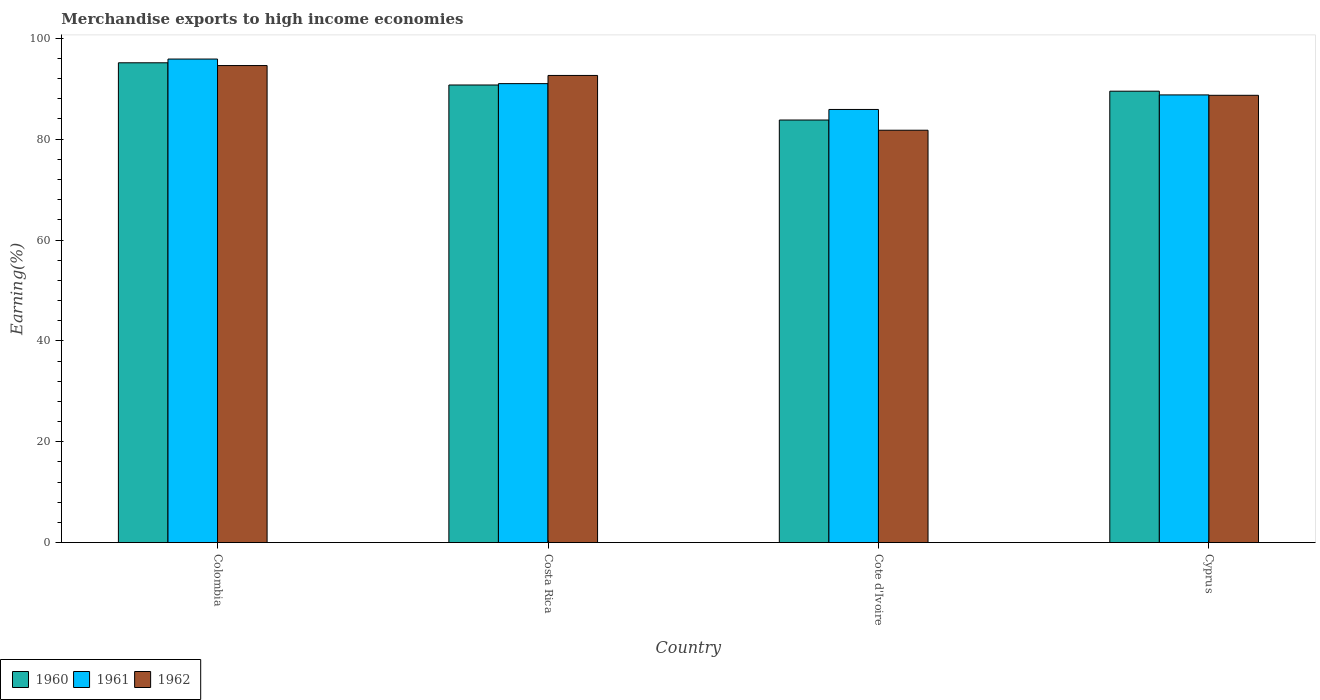How many groups of bars are there?
Make the answer very short. 4. Are the number of bars per tick equal to the number of legend labels?
Give a very brief answer. Yes. Are the number of bars on each tick of the X-axis equal?
Offer a very short reply. Yes. How many bars are there on the 4th tick from the left?
Offer a terse response. 3. How many bars are there on the 1st tick from the right?
Your answer should be very brief. 3. What is the percentage of amount earned from merchandise exports in 1962 in Costa Rica?
Provide a short and direct response. 92.64. Across all countries, what is the maximum percentage of amount earned from merchandise exports in 1960?
Provide a short and direct response. 95.14. Across all countries, what is the minimum percentage of amount earned from merchandise exports in 1961?
Make the answer very short. 85.89. In which country was the percentage of amount earned from merchandise exports in 1961 maximum?
Your answer should be very brief. Colombia. In which country was the percentage of amount earned from merchandise exports in 1961 minimum?
Ensure brevity in your answer.  Cote d'Ivoire. What is the total percentage of amount earned from merchandise exports in 1962 in the graph?
Ensure brevity in your answer.  357.7. What is the difference between the percentage of amount earned from merchandise exports in 1962 in Costa Rica and that in Cote d'Ivoire?
Make the answer very short. 10.87. What is the difference between the percentage of amount earned from merchandise exports in 1962 in Cyprus and the percentage of amount earned from merchandise exports in 1961 in Colombia?
Keep it short and to the point. -7.19. What is the average percentage of amount earned from merchandise exports in 1960 per country?
Give a very brief answer. 89.8. What is the difference between the percentage of amount earned from merchandise exports of/in 1961 and percentage of amount earned from merchandise exports of/in 1962 in Cyprus?
Make the answer very short. 0.08. In how many countries, is the percentage of amount earned from merchandise exports in 1962 greater than 72 %?
Offer a terse response. 4. What is the ratio of the percentage of amount earned from merchandise exports in 1960 in Colombia to that in Cyprus?
Make the answer very short. 1.06. Is the difference between the percentage of amount earned from merchandise exports in 1961 in Colombia and Cyprus greater than the difference between the percentage of amount earned from merchandise exports in 1962 in Colombia and Cyprus?
Your response must be concise. Yes. What is the difference between the highest and the second highest percentage of amount earned from merchandise exports in 1960?
Your answer should be very brief. -1.23. What is the difference between the highest and the lowest percentage of amount earned from merchandise exports in 1961?
Offer a terse response. 10. Is the sum of the percentage of amount earned from merchandise exports in 1960 in Colombia and Cyprus greater than the maximum percentage of amount earned from merchandise exports in 1962 across all countries?
Your response must be concise. Yes. What does the 1st bar from the right in Costa Rica represents?
Provide a succinct answer. 1962. How many bars are there?
Provide a short and direct response. 12. Are all the bars in the graph horizontal?
Keep it short and to the point. No. Are the values on the major ticks of Y-axis written in scientific E-notation?
Your answer should be very brief. No. How are the legend labels stacked?
Give a very brief answer. Horizontal. What is the title of the graph?
Offer a terse response. Merchandise exports to high income economies. What is the label or title of the Y-axis?
Offer a terse response. Earning(%). What is the Earning(%) of 1960 in Colombia?
Give a very brief answer. 95.14. What is the Earning(%) in 1961 in Colombia?
Keep it short and to the point. 95.89. What is the Earning(%) of 1962 in Colombia?
Make the answer very short. 94.6. What is the Earning(%) of 1960 in Costa Rica?
Your answer should be compact. 90.74. What is the Earning(%) in 1961 in Costa Rica?
Ensure brevity in your answer.  91.01. What is the Earning(%) in 1962 in Costa Rica?
Offer a very short reply. 92.64. What is the Earning(%) of 1960 in Cote d'Ivoire?
Provide a short and direct response. 83.8. What is the Earning(%) in 1961 in Cote d'Ivoire?
Offer a very short reply. 85.89. What is the Earning(%) in 1962 in Cote d'Ivoire?
Offer a very short reply. 81.77. What is the Earning(%) of 1960 in Cyprus?
Give a very brief answer. 89.51. What is the Earning(%) of 1961 in Cyprus?
Offer a terse response. 88.78. What is the Earning(%) of 1962 in Cyprus?
Give a very brief answer. 88.7. Across all countries, what is the maximum Earning(%) in 1960?
Make the answer very short. 95.14. Across all countries, what is the maximum Earning(%) in 1961?
Provide a short and direct response. 95.89. Across all countries, what is the maximum Earning(%) in 1962?
Provide a succinct answer. 94.6. Across all countries, what is the minimum Earning(%) of 1960?
Your answer should be very brief. 83.8. Across all countries, what is the minimum Earning(%) of 1961?
Provide a succinct answer. 85.89. Across all countries, what is the minimum Earning(%) in 1962?
Your answer should be very brief. 81.77. What is the total Earning(%) in 1960 in the graph?
Your answer should be compact. 359.19. What is the total Earning(%) of 1961 in the graph?
Your answer should be very brief. 361.56. What is the total Earning(%) in 1962 in the graph?
Your answer should be very brief. 357.7. What is the difference between the Earning(%) of 1960 in Colombia and that in Costa Rica?
Your answer should be compact. 4.4. What is the difference between the Earning(%) of 1961 in Colombia and that in Costa Rica?
Provide a succinct answer. 4.87. What is the difference between the Earning(%) of 1962 in Colombia and that in Costa Rica?
Provide a succinct answer. 1.96. What is the difference between the Earning(%) in 1960 in Colombia and that in Cote d'Ivoire?
Provide a succinct answer. 11.35. What is the difference between the Earning(%) of 1961 in Colombia and that in Cote d'Ivoire?
Keep it short and to the point. 10. What is the difference between the Earning(%) of 1962 in Colombia and that in Cote d'Ivoire?
Give a very brief answer. 12.83. What is the difference between the Earning(%) in 1960 in Colombia and that in Cyprus?
Your answer should be very brief. 5.63. What is the difference between the Earning(%) of 1961 in Colombia and that in Cyprus?
Give a very brief answer. 7.11. What is the difference between the Earning(%) of 1962 in Colombia and that in Cyprus?
Your answer should be very brief. 5.9. What is the difference between the Earning(%) in 1960 in Costa Rica and that in Cote d'Ivoire?
Provide a short and direct response. 6.95. What is the difference between the Earning(%) in 1961 in Costa Rica and that in Cote d'Ivoire?
Your answer should be very brief. 5.12. What is the difference between the Earning(%) in 1962 in Costa Rica and that in Cote d'Ivoire?
Your response must be concise. 10.87. What is the difference between the Earning(%) in 1960 in Costa Rica and that in Cyprus?
Provide a short and direct response. 1.23. What is the difference between the Earning(%) of 1961 in Costa Rica and that in Cyprus?
Your answer should be very brief. 2.24. What is the difference between the Earning(%) in 1962 in Costa Rica and that in Cyprus?
Make the answer very short. 3.94. What is the difference between the Earning(%) in 1960 in Cote d'Ivoire and that in Cyprus?
Provide a short and direct response. -5.72. What is the difference between the Earning(%) in 1961 in Cote d'Ivoire and that in Cyprus?
Offer a terse response. -2.88. What is the difference between the Earning(%) of 1962 in Cote d'Ivoire and that in Cyprus?
Your answer should be compact. -6.92. What is the difference between the Earning(%) in 1960 in Colombia and the Earning(%) in 1961 in Costa Rica?
Your answer should be compact. 4.13. What is the difference between the Earning(%) of 1960 in Colombia and the Earning(%) of 1962 in Costa Rica?
Offer a terse response. 2.51. What is the difference between the Earning(%) in 1961 in Colombia and the Earning(%) in 1962 in Costa Rica?
Offer a very short reply. 3.25. What is the difference between the Earning(%) in 1960 in Colombia and the Earning(%) in 1961 in Cote d'Ivoire?
Provide a short and direct response. 9.25. What is the difference between the Earning(%) of 1960 in Colombia and the Earning(%) of 1962 in Cote d'Ivoire?
Offer a very short reply. 13.37. What is the difference between the Earning(%) of 1961 in Colombia and the Earning(%) of 1962 in Cote d'Ivoire?
Offer a terse response. 14.11. What is the difference between the Earning(%) of 1960 in Colombia and the Earning(%) of 1961 in Cyprus?
Ensure brevity in your answer.  6.37. What is the difference between the Earning(%) of 1960 in Colombia and the Earning(%) of 1962 in Cyprus?
Make the answer very short. 6.45. What is the difference between the Earning(%) in 1961 in Colombia and the Earning(%) in 1962 in Cyprus?
Keep it short and to the point. 7.19. What is the difference between the Earning(%) in 1960 in Costa Rica and the Earning(%) in 1961 in Cote d'Ivoire?
Provide a short and direct response. 4.85. What is the difference between the Earning(%) of 1960 in Costa Rica and the Earning(%) of 1962 in Cote d'Ivoire?
Your response must be concise. 8.97. What is the difference between the Earning(%) of 1961 in Costa Rica and the Earning(%) of 1962 in Cote d'Ivoire?
Your response must be concise. 9.24. What is the difference between the Earning(%) in 1960 in Costa Rica and the Earning(%) in 1961 in Cyprus?
Provide a short and direct response. 1.97. What is the difference between the Earning(%) in 1960 in Costa Rica and the Earning(%) in 1962 in Cyprus?
Keep it short and to the point. 2.05. What is the difference between the Earning(%) of 1961 in Costa Rica and the Earning(%) of 1962 in Cyprus?
Your answer should be very brief. 2.32. What is the difference between the Earning(%) of 1960 in Cote d'Ivoire and the Earning(%) of 1961 in Cyprus?
Give a very brief answer. -4.98. What is the difference between the Earning(%) of 1960 in Cote d'Ivoire and the Earning(%) of 1962 in Cyprus?
Your answer should be very brief. -4.9. What is the difference between the Earning(%) in 1961 in Cote d'Ivoire and the Earning(%) in 1962 in Cyprus?
Your answer should be compact. -2.8. What is the average Earning(%) in 1960 per country?
Your answer should be compact. 89.8. What is the average Earning(%) of 1961 per country?
Give a very brief answer. 90.39. What is the average Earning(%) of 1962 per country?
Offer a very short reply. 89.42. What is the difference between the Earning(%) in 1960 and Earning(%) in 1961 in Colombia?
Your answer should be compact. -0.74. What is the difference between the Earning(%) in 1960 and Earning(%) in 1962 in Colombia?
Ensure brevity in your answer.  0.55. What is the difference between the Earning(%) in 1961 and Earning(%) in 1962 in Colombia?
Ensure brevity in your answer.  1.29. What is the difference between the Earning(%) of 1960 and Earning(%) of 1961 in Costa Rica?
Provide a short and direct response. -0.27. What is the difference between the Earning(%) of 1960 and Earning(%) of 1962 in Costa Rica?
Provide a succinct answer. -1.9. What is the difference between the Earning(%) in 1961 and Earning(%) in 1962 in Costa Rica?
Your response must be concise. -1.63. What is the difference between the Earning(%) of 1960 and Earning(%) of 1961 in Cote d'Ivoire?
Offer a terse response. -2.1. What is the difference between the Earning(%) in 1960 and Earning(%) in 1962 in Cote d'Ivoire?
Give a very brief answer. 2.02. What is the difference between the Earning(%) in 1961 and Earning(%) in 1962 in Cote d'Ivoire?
Ensure brevity in your answer.  4.12. What is the difference between the Earning(%) of 1960 and Earning(%) of 1961 in Cyprus?
Offer a terse response. 0.74. What is the difference between the Earning(%) of 1960 and Earning(%) of 1962 in Cyprus?
Your answer should be very brief. 0.82. What is the difference between the Earning(%) of 1961 and Earning(%) of 1962 in Cyprus?
Your answer should be very brief. 0.08. What is the ratio of the Earning(%) in 1960 in Colombia to that in Costa Rica?
Your answer should be compact. 1.05. What is the ratio of the Earning(%) in 1961 in Colombia to that in Costa Rica?
Offer a very short reply. 1.05. What is the ratio of the Earning(%) of 1962 in Colombia to that in Costa Rica?
Ensure brevity in your answer.  1.02. What is the ratio of the Earning(%) of 1960 in Colombia to that in Cote d'Ivoire?
Make the answer very short. 1.14. What is the ratio of the Earning(%) of 1961 in Colombia to that in Cote d'Ivoire?
Ensure brevity in your answer.  1.12. What is the ratio of the Earning(%) in 1962 in Colombia to that in Cote d'Ivoire?
Your response must be concise. 1.16. What is the ratio of the Earning(%) in 1960 in Colombia to that in Cyprus?
Ensure brevity in your answer.  1.06. What is the ratio of the Earning(%) in 1961 in Colombia to that in Cyprus?
Your answer should be very brief. 1.08. What is the ratio of the Earning(%) of 1962 in Colombia to that in Cyprus?
Give a very brief answer. 1.07. What is the ratio of the Earning(%) of 1960 in Costa Rica to that in Cote d'Ivoire?
Your answer should be compact. 1.08. What is the ratio of the Earning(%) of 1961 in Costa Rica to that in Cote d'Ivoire?
Ensure brevity in your answer.  1.06. What is the ratio of the Earning(%) of 1962 in Costa Rica to that in Cote d'Ivoire?
Provide a short and direct response. 1.13. What is the ratio of the Earning(%) of 1960 in Costa Rica to that in Cyprus?
Your answer should be compact. 1.01. What is the ratio of the Earning(%) in 1961 in Costa Rica to that in Cyprus?
Your answer should be compact. 1.03. What is the ratio of the Earning(%) of 1962 in Costa Rica to that in Cyprus?
Offer a very short reply. 1.04. What is the ratio of the Earning(%) of 1960 in Cote d'Ivoire to that in Cyprus?
Ensure brevity in your answer.  0.94. What is the ratio of the Earning(%) of 1961 in Cote d'Ivoire to that in Cyprus?
Keep it short and to the point. 0.97. What is the ratio of the Earning(%) in 1962 in Cote d'Ivoire to that in Cyprus?
Provide a succinct answer. 0.92. What is the difference between the highest and the second highest Earning(%) of 1960?
Ensure brevity in your answer.  4.4. What is the difference between the highest and the second highest Earning(%) in 1961?
Offer a very short reply. 4.87. What is the difference between the highest and the second highest Earning(%) in 1962?
Keep it short and to the point. 1.96. What is the difference between the highest and the lowest Earning(%) in 1960?
Provide a succinct answer. 11.35. What is the difference between the highest and the lowest Earning(%) of 1961?
Offer a terse response. 10. What is the difference between the highest and the lowest Earning(%) in 1962?
Give a very brief answer. 12.83. 